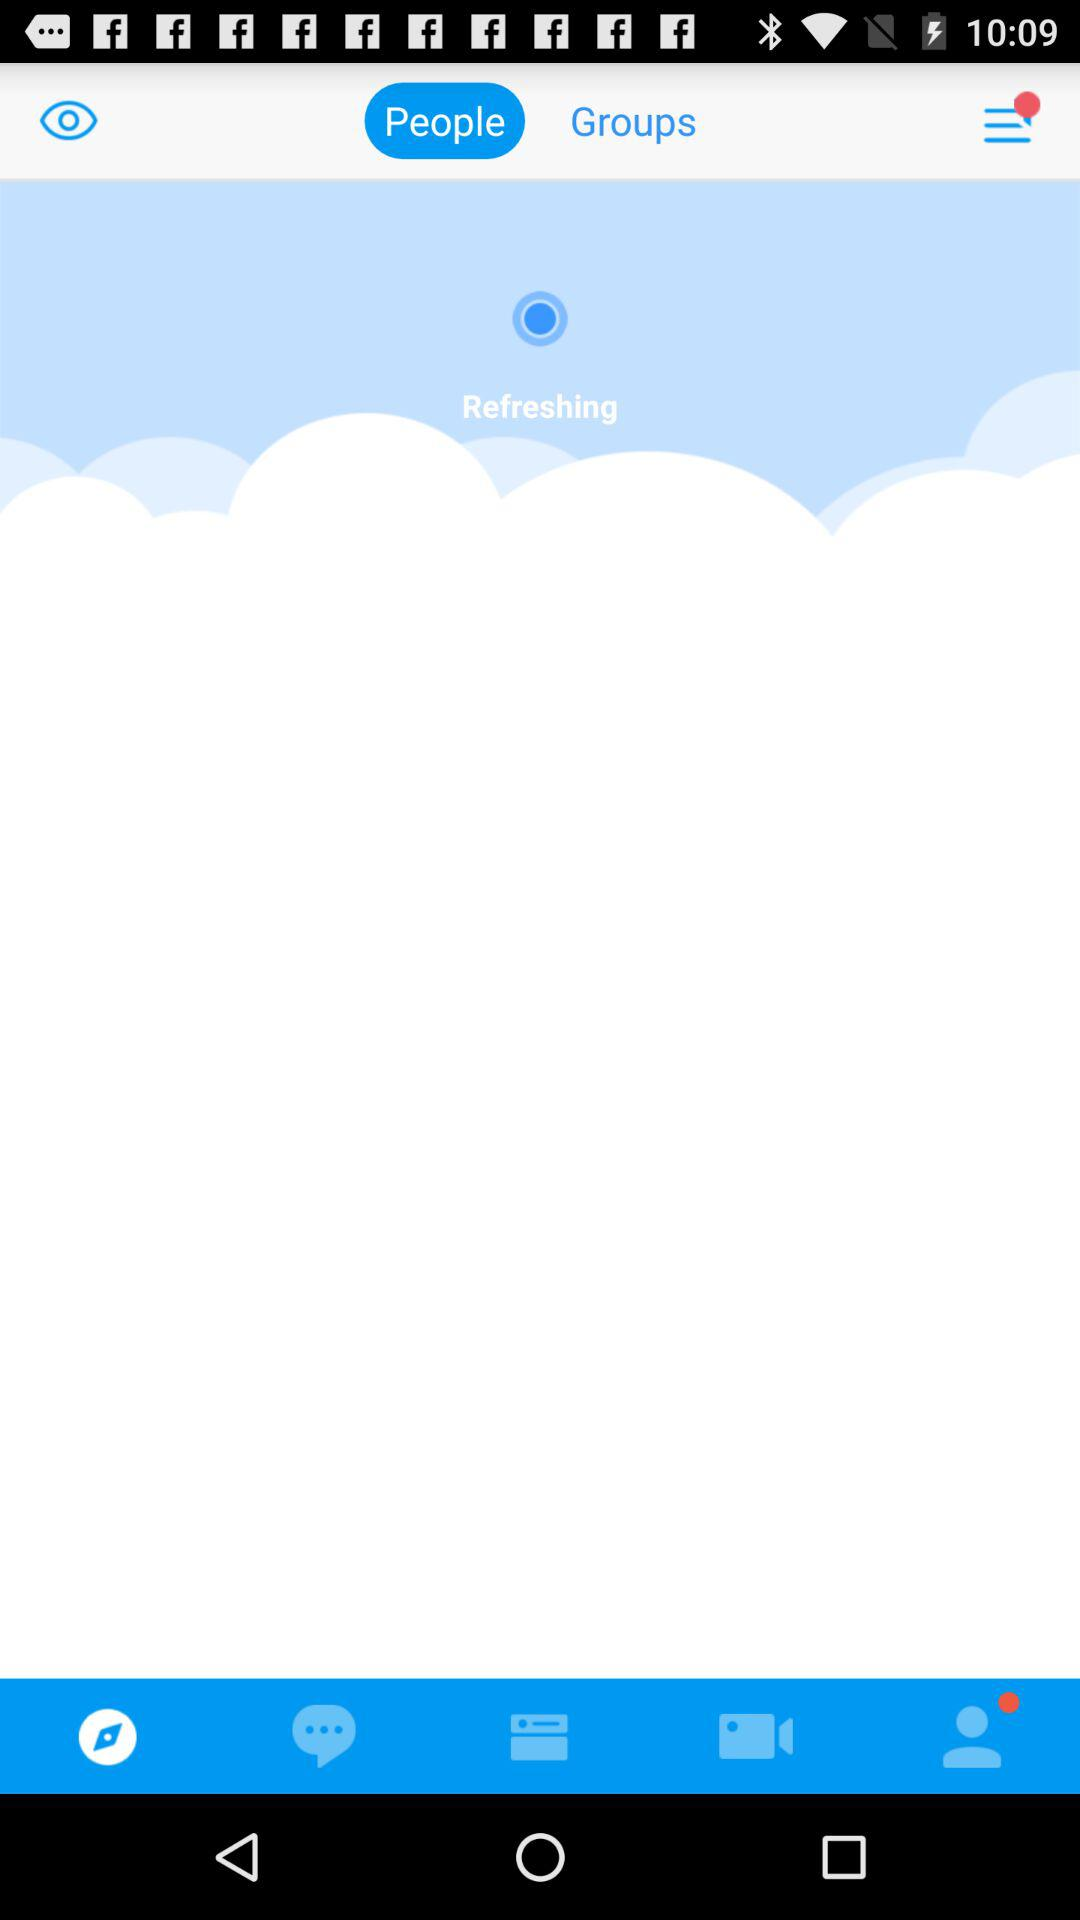What is the final step? The final step is to "Complete your profile to embrace the colorful community!". 